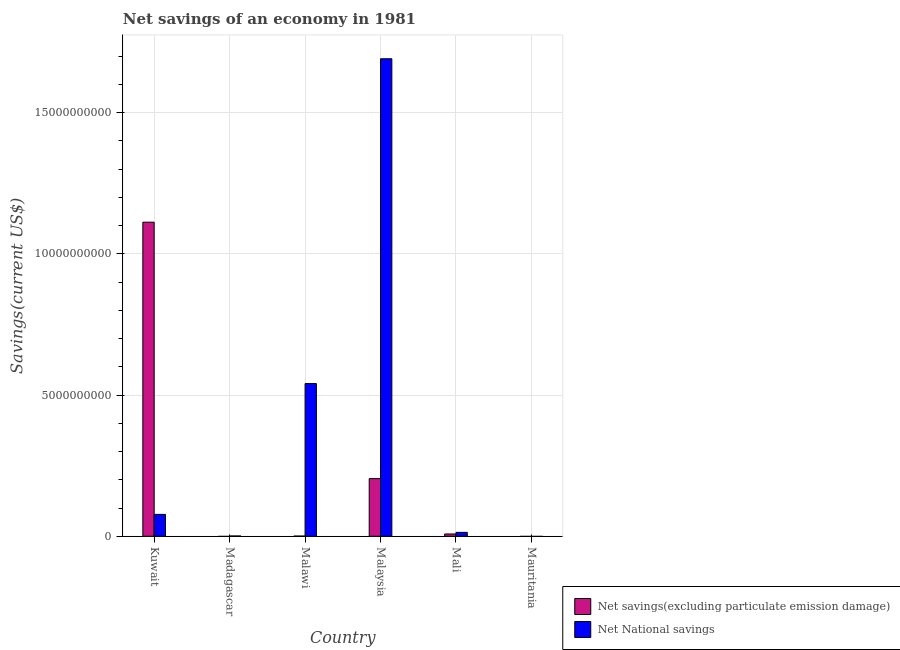Are the number of bars on each tick of the X-axis equal?
Provide a short and direct response. No. What is the label of the 2nd group of bars from the left?
Offer a very short reply. Madagascar. In how many cases, is the number of bars for a given country not equal to the number of legend labels?
Your answer should be compact. 2. What is the net savings(excluding particulate emission damage) in Malawi?
Keep it short and to the point. 5.62e+06. Across all countries, what is the maximum net savings(excluding particulate emission damage)?
Your response must be concise. 1.11e+1. In which country was the net national savings maximum?
Your response must be concise. Malaysia. What is the total net national savings in the graph?
Make the answer very short. 2.32e+1. What is the difference between the net savings(excluding particulate emission damage) in Malaysia and that in Mali?
Offer a terse response. 1.96e+09. What is the difference between the net national savings in Malaysia and the net savings(excluding particulate emission damage) in Madagascar?
Your answer should be very brief. 1.69e+1. What is the average net national savings per country?
Your answer should be very brief. 3.87e+09. What is the difference between the net savings(excluding particulate emission damage) and net national savings in Mali?
Your answer should be very brief. -5.71e+07. In how many countries, is the net national savings greater than 12000000000 US$?
Provide a succinct answer. 1. What is the ratio of the net national savings in Malaysia to that in Mali?
Your response must be concise. 122.78. What is the difference between the highest and the second highest net savings(excluding particulate emission damage)?
Your response must be concise. 9.08e+09. What is the difference between the highest and the lowest net national savings?
Your answer should be very brief. 1.69e+1. In how many countries, is the net savings(excluding particulate emission damage) greater than the average net savings(excluding particulate emission damage) taken over all countries?
Your response must be concise. 1. How many countries are there in the graph?
Offer a very short reply. 6. Are the values on the major ticks of Y-axis written in scientific E-notation?
Provide a succinct answer. No. Does the graph contain any zero values?
Offer a terse response. Yes. Does the graph contain grids?
Your answer should be very brief. Yes. Where does the legend appear in the graph?
Offer a very short reply. Bottom right. What is the title of the graph?
Your answer should be very brief. Net savings of an economy in 1981. Does "Urban agglomerations" appear as one of the legend labels in the graph?
Provide a succinct answer. No. What is the label or title of the X-axis?
Make the answer very short. Country. What is the label or title of the Y-axis?
Offer a terse response. Savings(current US$). What is the Savings(current US$) of Net savings(excluding particulate emission damage) in Kuwait?
Keep it short and to the point. 1.11e+1. What is the Savings(current US$) of Net National savings in Kuwait?
Offer a terse response. 7.74e+08. What is the Savings(current US$) of Net savings(excluding particulate emission damage) in Madagascar?
Offer a terse response. 0. What is the Savings(current US$) of Net National savings in Madagascar?
Ensure brevity in your answer.  9.69e+06. What is the Savings(current US$) in Net savings(excluding particulate emission damage) in Malawi?
Ensure brevity in your answer.  5.62e+06. What is the Savings(current US$) in Net National savings in Malawi?
Your answer should be very brief. 5.41e+09. What is the Savings(current US$) of Net savings(excluding particulate emission damage) in Malaysia?
Your answer should be compact. 2.04e+09. What is the Savings(current US$) in Net National savings in Malaysia?
Offer a terse response. 1.69e+1. What is the Savings(current US$) in Net savings(excluding particulate emission damage) in Mali?
Ensure brevity in your answer.  8.07e+07. What is the Savings(current US$) in Net National savings in Mali?
Provide a short and direct response. 1.38e+08. Across all countries, what is the maximum Savings(current US$) in Net savings(excluding particulate emission damage)?
Your answer should be very brief. 1.11e+1. Across all countries, what is the maximum Savings(current US$) of Net National savings?
Provide a succinct answer. 1.69e+1. What is the total Savings(current US$) in Net savings(excluding particulate emission damage) in the graph?
Your answer should be compact. 1.33e+1. What is the total Savings(current US$) of Net National savings in the graph?
Your answer should be very brief. 2.32e+1. What is the difference between the Savings(current US$) of Net National savings in Kuwait and that in Madagascar?
Offer a very short reply. 7.65e+08. What is the difference between the Savings(current US$) of Net savings(excluding particulate emission damage) in Kuwait and that in Malawi?
Your answer should be very brief. 1.11e+1. What is the difference between the Savings(current US$) of Net National savings in Kuwait and that in Malawi?
Offer a terse response. -4.63e+09. What is the difference between the Savings(current US$) of Net savings(excluding particulate emission damage) in Kuwait and that in Malaysia?
Your response must be concise. 9.08e+09. What is the difference between the Savings(current US$) of Net National savings in Kuwait and that in Malaysia?
Offer a terse response. -1.61e+1. What is the difference between the Savings(current US$) in Net savings(excluding particulate emission damage) in Kuwait and that in Mali?
Your answer should be compact. 1.10e+1. What is the difference between the Savings(current US$) of Net National savings in Kuwait and that in Mali?
Provide a succinct answer. 6.37e+08. What is the difference between the Savings(current US$) of Net National savings in Madagascar and that in Malawi?
Give a very brief answer. -5.40e+09. What is the difference between the Savings(current US$) of Net National savings in Madagascar and that in Malaysia?
Offer a very short reply. -1.69e+1. What is the difference between the Savings(current US$) in Net National savings in Madagascar and that in Mali?
Your answer should be compact. -1.28e+08. What is the difference between the Savings(current US$) in Net savings(excluding particulate emission damage) in Malawi and that in Malaysia?
Make the answer very short. -2.04e+09. What is the difference between the Savings(current US$) in Net National savings in Malawi and that in Malaysia?
Keep it short and to the point. -1.15e+1. What is the difference between the Savings(current US$) in Net savings(excluding particulate emission damage) in Malawi and that in Mali?
Make the answer very short. -7.50e+07. What is the difference between the Savings(current US$) in Net National savings in Malawi and that in Mali?
Keep it short and to the point. 5.27e+09. What is the difference between the Savings(current US$) of Net savings(excluding particulate emission damage) in Malaysia and that in Mali?
Your response must be concise. 1.96e+09. What is the difference between the Savings(current US$) of Net National savings in Malaysia and that in Mali?
Provide a short and direct response. 1.68e+1. What is the difference between the Savings(current US$) of Net savings(excluding particulate emission damage) in Kuwait and the Savings(current US$) of Net National savings in Madagascar?
Offer a terse response. 1.11e+1. What is the difference between the Savings(current US$) of Net savings(excluding particulate emission damage) in Kuwait and the Savings(current US$) of Net National savings in Malawi?
Ensure brevity in your answer.  5.72e+09. What is the difference between the Savings(current US$) of Net savings(excluding particulate emission damage) in Kuwait and the Savings(current US$) of Net National savings in Malaysia?
Ensure brevity in your answer.  -5.79e+09. What is the difference between the Savings(current US$) in Net savings(excluding particulate emission damage) in Kuwait and the Savings(current US$) in Net National savings in Mali?
Make the answer very short. 1.10e+1. What is the difference between the Savings(current US$) of Net savings(excluding particulate emission damage) in Malawi and the Savings(current US$) of Net National savings in Malaysia?
Ensure brevity in your answer.  -1.69e+1. What is the difference between the Savings(current US$) of Net savings(excluding particulate emission damage) in Malawi and the Savings(current US$) of Net National savings in Mali?
Give a very brief answer. -1.32e+08. What is the difference between the Savings(current US$) of Net savings(excluding particulate emission damage) in Malaysia and the Savings(current US$) of Net National savings in Mali?
Offer a very short reply. 1.90e+09. What is the average Savings(current US$) in Net savings(excluding particulate emission damage) per country?
Make the answer very short. 2.21e+09. What is the average Savings(current US$) in Net National savings per country?
Offer a very short reply. 3.87e+09. What is the difference between the Savings(current US$) in Net savings(excluding particulate emission damage) and Savings(current US$) in Net National savings in Kuwait?
Your answer should be compact. 1.03e+1. What is the difference between the Savings(current US$) in Net savings(excluding particulate emission damage) and Savings(current US$) in Net National savings in Malawi?
Make the answer very short. -5.40e+09. What is the difference between the Savings(current US$) in Net savings(excluding particulate emission damage) and Savings(current US$) in Net National savings in Malaysia?
Your answer should be very brief. -1.49e+1. What is the difference between the Savings(current US$) in Net savings(excluding particulate emission damage) and Savings(current US$) in Net National savings in Mali?
Make the answer very short. -5.71e+07. What is the ratio of the Savings(current US$) of Net National savings in Kuwait to that in Madagascar?
Your response must be concise. 79.9. What is the ratio of the Savings(current US$) in Net savings(excluding particulate emission damage) in Kuwait to that in Malawi?
Keep it short and to the point. 1980.64. What is the ratio of the Savings(current US$) of Net National savings in Kuwait to that in Malawi?
Your answer should be very brief. 0.14. What is the ratio of the Savings(current US$) of Net savings(excluding particulate emission damage) in Kuwait to that in Malaysia?
Give a very brief answer. 5.45. What is the ratio of the Savings(current US$) in Net National savings in Kuwait to that in Malaysia?
Ensure brevity in your answer.  0.05. What is the ratio of the Savings(current US$) of Net savings(excluding particulate emission damage) in Kuwait to that in Mali?
Your response must be concise. 137.93. What is the ratio of the Savings(current US$) of Net National savings in Kuwait to that in Mali?
Offer a very short reply. 5.62. What is the ratio of the Savings(current US$) in Net National savings in Madagascar to that in Malawi?
Your response must be concise. 0. What is the ratio of the Savings(current US$) of Net National savings in Madagascar to that in Malaysia?
Ensure brevity in your answer.  0. What is the ratio of the Savings(current US$) in Net National savings in Madagascar to that in Mali?
Keep it short and to the point. 0.07. What is the ratio of the Savings(current US$) in Net savings(excluding particulate emission damage) in Malawi to that in Malaysia?
Make the answer very short. 0. What is the ratio of the Savings(current US$) in Net National savings in Malawi to that in Malaysia?
Offer a terse response. 0.32. What is the ratio of the Savings(current US$) in Net savings(excluding particulate emission damage) in Malawi to that in Mali?
Your response must be concise. 0.07. What is the ratio of the Savings(current US$) in Net National savings in Malawi to that in Mali?
Ensure brevity in your answer.  39.26. What is the ratio of the Savings(current US$) of Net savings(excluding particulate emission damage) in Malaysia to that in Mali?
Your answer should be compact. 25.3. What is the ratio of the Savings(current US$) in Net National savings in Malaysia to that in Mali?
Provide a short and direct response. 122.78. What is the difference between the highest and the second highest Savings(current US$) in Net savings(excluding particulate emission damage)?
Keep it short and to the point. 9.08e+09. What is the difference between the highest and the second highest Savings(current US$) of Net National savings?
Give a very brief answer. 1.15e+1. What is the difference between the highest and the lowest Savings(current US$) in Net savings(excluding particulate emission damage)?
Your answer should be compact. 1.11e+1. What is the difference between the highest and the lowest Savings(current US$) of Net National savings?
Offer a terse response. 1.69e+1. 